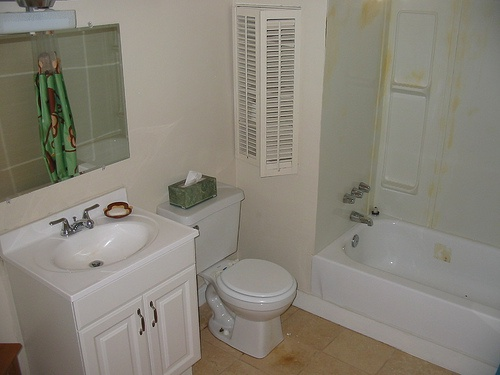Describe the objects in this image and their specific colors. I can see sink in black, darkgray, and gray tones and toilet in black and gray tones in this image. 